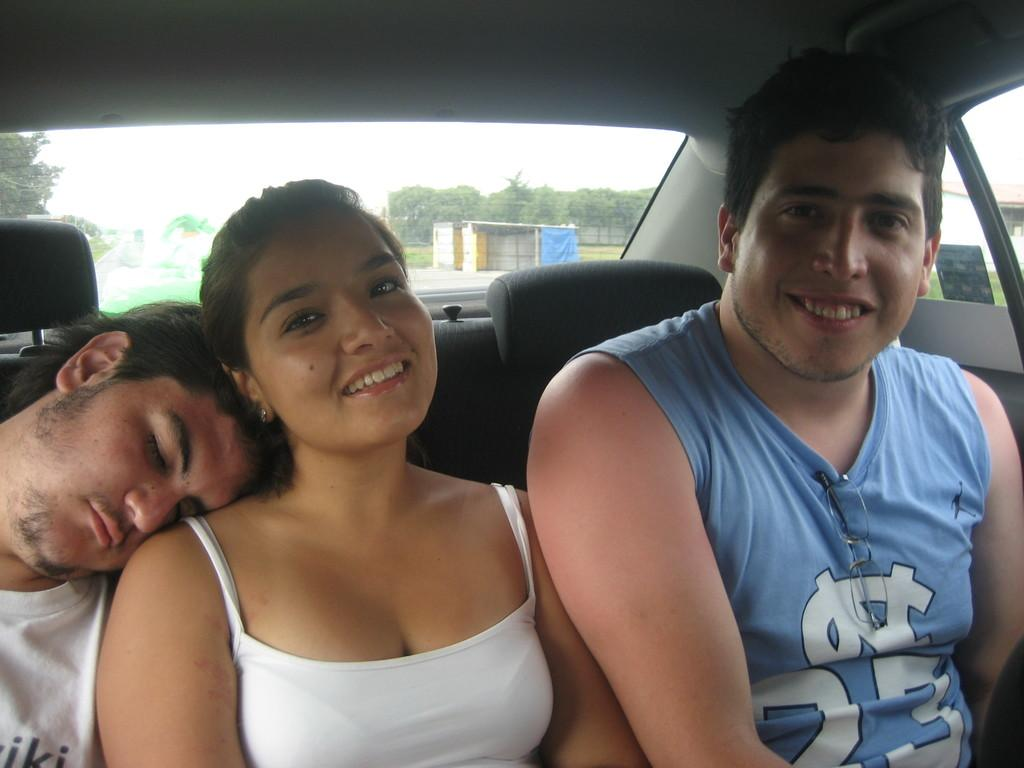How many people are in the image? There are three people in the image. Where are the people seated in the image? The people are seated in a car. Can you describe their location within the car? The people are seated in the back of the car. What type of letters can be seen on the car's license plate in the image? There is no information about a license plate or letters on it in the image. 